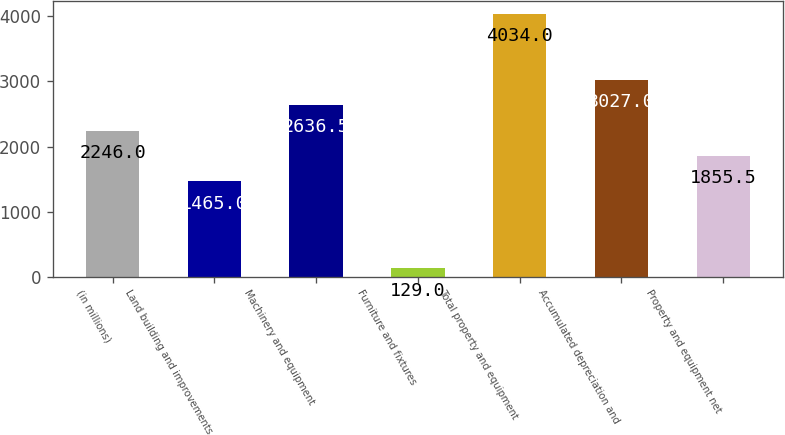Convert chart. <chart><loc_0><loc_0><loc_500><loc_500><bar_chart><fcel>(in millions)<fcel>Land building and improvements<fcel>Machinery and equipment<fcel>Furniture and fixtures<fcel>Total property and equipment<fcel>Accumulated depreciation and<fcel>Property and equipment net<nl><fcel>2246<fcel>1465<fcel>2636.5<fcel>129<fcel>4034<fcel>3027<fcel>1855.5<nl></chart> 